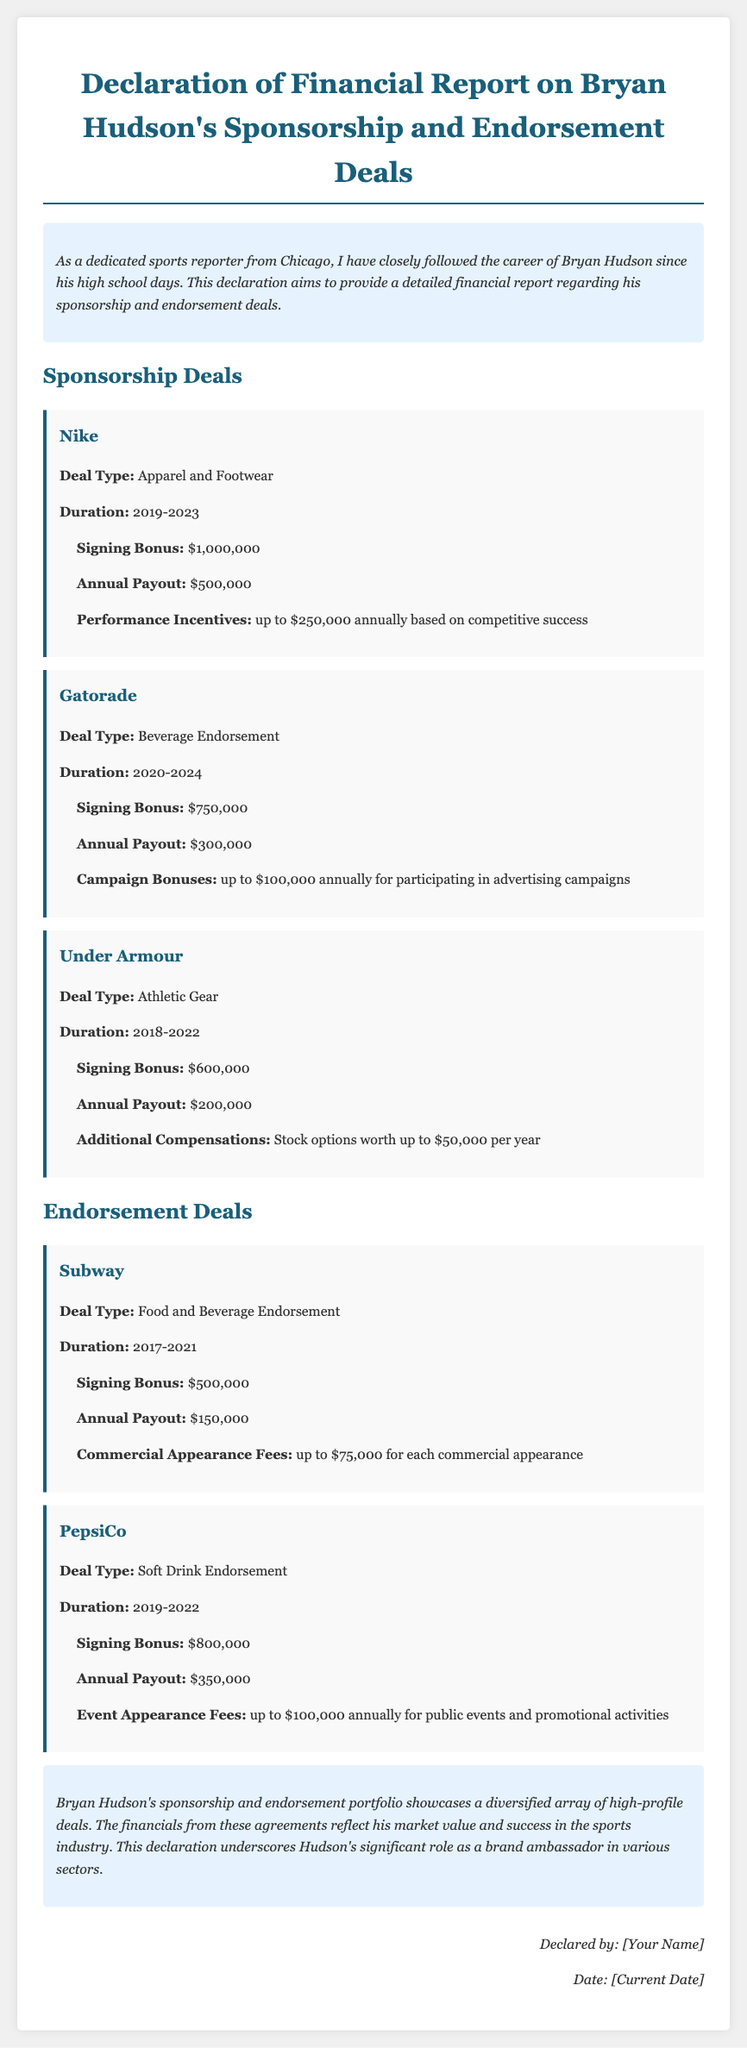What is Bryan Hudson's signing bonus from Nike? The signing bonus from Nike is listed in the document as $1,000,000.
Answer: $1,000,000 What is the annual payout from Gatorade? The annual payout from Gatorade is stated as $300,000 in the document.
Answer: $300,000 For how many years is the Under Armour deal? The duration of the Under Armour deal is indicated as 2018-2022, which is 5 years.
Answer: 5 years What kind of deal is PepsiCo associated with? The deal type for PepsiCo is described as Soft Drink Endorsement in the document.
Answer: Soft Drink Endorsement What is the maximum performance incentive for Bryan Hudson with Nike? The maximum performance incentive with Nike is noted as up to $250,000 annually.
Answer: up to $250,000 annually How much can Bryan earn annually from Subway commercial appearances? The document states that Bryan can earn up to $75,000 for each commercial appearance with Subway.
Answer: up to $75,000 What is the total duration of the Gatorade sponsorship deal? The duration of the Gatorade sponsorship deal is from 2020 to 2024, totaling 5 years.
Answer: 5 years Who declared the financial report? The declaration states that the report was declared by "[Your Name]".
Answer: [Your Name] 